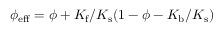Convert formula to latex. <formula><loc_0><loc_0><loc_500><loc_500>\phi _ { e f f } = \phi + K _ { f } / K _ { s } ( 1 - \phi - K _ { b } / K _ { s } )</formula> 